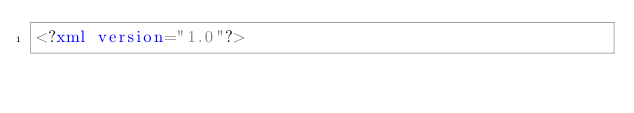Convert code to text. <code><loc_0><loc_0><loc_500><loc_500><_XML_><?xml version="1.0"?></code> 